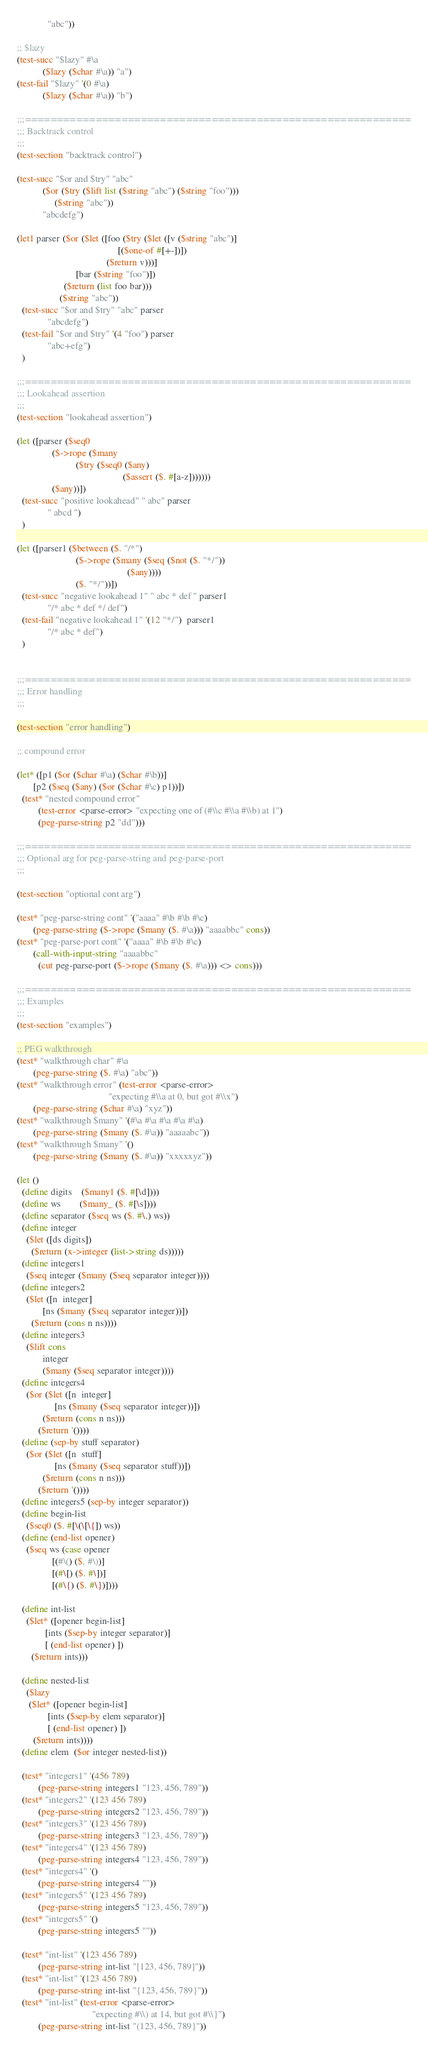<code> <loc_0><loc_0><loc_500><loc_500><_Scheme_>             "abc"))

;; $lazy
(test-succ "$lazy" #\a
           ($lazy ($char #\a)) "a")
(test-fail "$lazy" '(0 #\a)
           ($lazy ($char #\a)) "b")

;;;============================================================
;;; Backtrack control
;;;
(test-section "backtrack control")

(test-succ "$or and $try" "abc"
           ($or ($try ($lift list ($string "abc") ($string "foo")))
                ($string "abc"))
           "abcdefg")

(let1 parser ($or ($let ([foo ($try ($let ([v ($string "abc")]
                                           [($one-of #[+-])])
                                      ($return v)))]
                         [bar ($string "foo")])
                    ($return (list foo bar)))
                  ($string "abc"))
  (test-succ "$or and $try" "abc" parser
             "abcdefg")
  (test-fail "$or and $try" '(4 "foo") parser
             "abc+efg")
  )

;;;============================================================
;;; Lookahead assertion
;;;
(test-section "lookahead assertion")

(let ([parser ($seq0 
               ($->rope ($many 
                         ($try ($seq0 ($any)
                                             ($assert ($. #[a-z]))))))
               ($any))])
  (test-succ "positive lookahead" " abc" parser
             " abcd ")
  )

(let ([parser1 ($between ($. "/*")
                         ($->rope ($many ($seq ($not ($. "*/"))
                                               ($any))))
                         ($. "*/"))])
  (test-succ "negative lookahead 1" " abc * def " parser1
             "/* abc * def */ def")
  (test-fail "negative lookahead 1" '(12 "*/")  parser1
             "/* abc * def")
  )


;;;============================================================
;;; Error handling
;;;

(test-section "error handling")

;; compound error

(let* ([p1 ($or ($char #\a) ($char #\b))]
       [p2 ($seq ($any) ($or ($char #\c) p1))])
  (test* "nested compound error"
         (test-error <parse-error> "expecting one of (#\\c #\\a #\\b) at 1")
         (peg-parse-string p2 "dd")))

;;;============================================================
;;; Optional arg for peg-parse-string and peg-parse-port
;;;

(test-section "optional cont arg")

(test* "peg-parse-string cont" '("aaaa" #\b #\b #\c)
       (peg-parse-string ($->rope ($many ($. #\a))) "aaaabbc" cons))
(test* "peg-parse-port cont" '("aaaa" #\b #\b #\c)
       (call-with-input-string "aaaabbc"
         (cut peg-parse-port ($->rope ($many ($. #\a))) <> cons)))

;;;============================================================
;;; Examples
;;;
(test-section "examples")

;; PEG walkthrough
(test* "walkthrough char" #\a
       (peg-parse-string ($. #\a) "abc"))
(test* "walkthrough error" (test-error <parse-error>
                                       "expecting #\\a at 0, but got #\\x")
       (peg-parse-string ($char #\a) "xyz"))
(test* "walkthrough $many" '(#\a #\a #\a #\a #\a)
       (peg-parse-string ($many ($. #\a)) "aaaaabc"))
(test* "walkthrough $many" '()
       (peg-parse-string ($many ($. #\a)) "xxxxxyz"))

(let ()
  (define digits    ($many1 ($. #[\d])))
  (define ws        ($many_ ($. #[\s])))
  (define separator ($seq ws ($. #\,) ws))
  (define integer
    ($let ([ds digits])
      ($return (x->integer (list->string ds)))))
  (define integers1 
    ($seq integer ($many ($seq separator integer))))
  (define integers2 
    ($let ([n  integer]
           [ns ($many ($seq separator integer))])
      ($return (cons n ns))))
  (define integers3
    ($lift cons
           integer
           ($many ($seq separator integer))))
  (define integers4
    ($or ($let ([n  integer]
                [ns ($many ($seq separator integer))])
           ($return (cons n ns)))
         ($return '())))
  (define (sep-by stuff separator)
    ($or ($let ([n  stuff]
                [ns ($many ($seq separator stuff))])
           ($return (cons n ns)))
         ($return '())))
  (define integers5 (sep-by integer separator))
  (define begin-list 
    ($seq0 ($. #[\(\[\{]) ws))
  (define (end-list opener) 
    ($seq ws (case opener
               [(#\() ($. #\))]
               [(#\[) ($. #\])]
               [(#\{) ($. #\})])))
  
  (define int-list
    ($let* ([opener begin-list]
            [ints ($sep-by integer separator)]
            [ (end-list opener) ])
      ($return ints)))

  (define nested-list
    ($lazy
     ($let* ([opener begin-list]
             [ints ($sep-by elem separator)]
             [ (end-list opener) ])
       ($return ints))))
  (define elem  ($or integer nested-list))

  (test* "integers1" '(456 789)
         (peg-parse-string integers1 "123, 456, 789"))
  (test* "integers2" '(123 456 789)
         (peg-parse-string integers2 "123, 456, 789"))
  (test* "integers3" '(123 456 789)
         (peg-parse-string integers3 "123, 456, 789"))
  (test* "integers4" '(123 456 789)
         (peg-parse-string integers4 "123, 456, 789"))
  (test* "integers4" '()
         (peg-parse-string integers4 ""))
  (test* "integers5" '(123 456 789)
         (peg-parse-string integers5 "123, 456, 789"))
  (test* "integers5" '()
         (peg-parse-string integers5 ""))

  (test* "int-list" '(123 456 789)
         (peg-parse-string int-list "[123, 456, 789]"))
  (test* "int-list" '(123 456 789)
         (peg-parse-string int-list "{123, 456, 789}"))
  (test* "int-list" (test-error <parse-error>
                                "expecting #\\) at 14, but got #\\}")
         (peg-parse-string int-list "(123, 456, 789}"))
</code> 